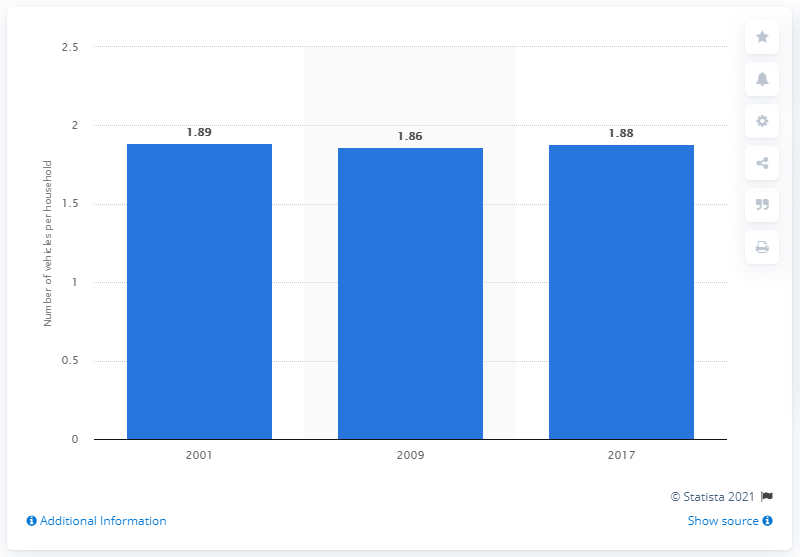Outline some significant characteristics in this image. On average, each household in the United States owns 1.88 vehicles. 